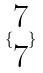<formula> <loc_0><loc_0><loc_500><loc_500>\{ \begin{matrix} 7 \\ 7 \end{matrix} \}</formula> 